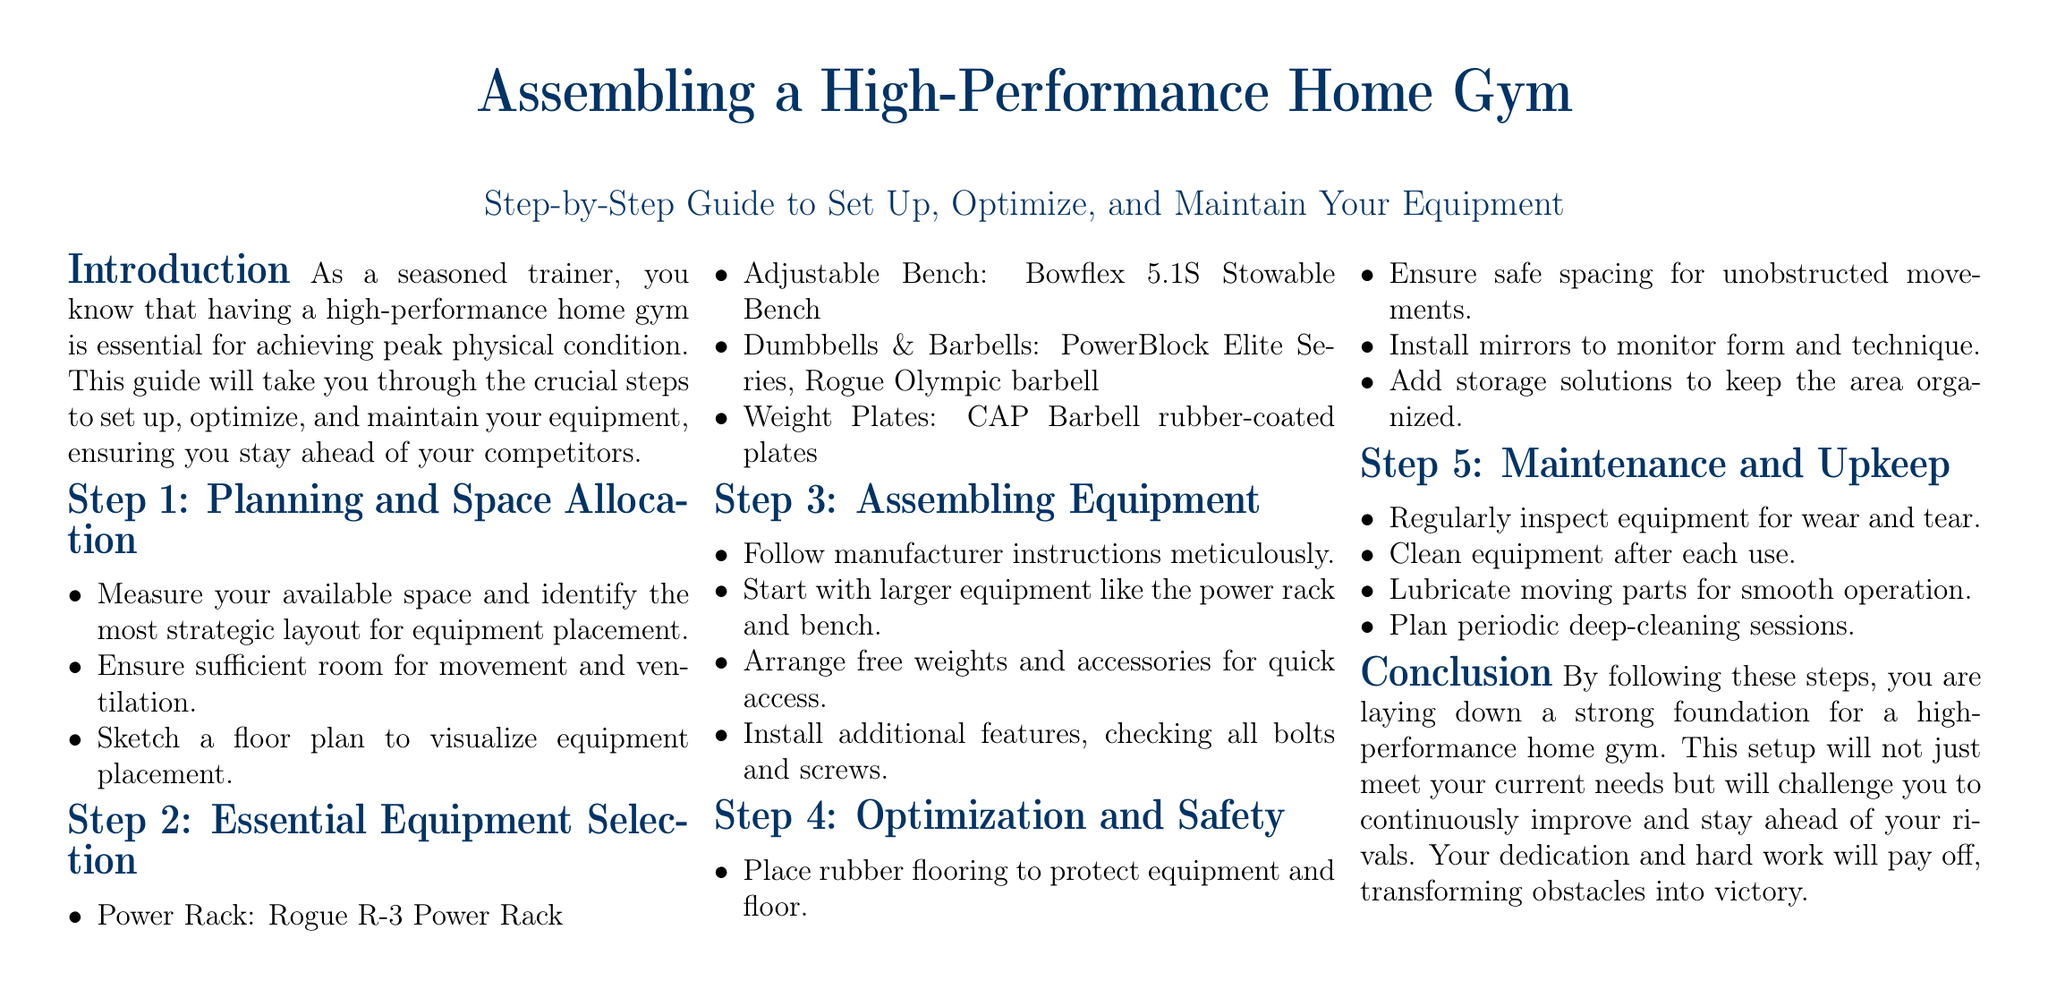What is the first step in assembling a home gym? The first step is planning and space allocation, as indicated in the document.
Answer: Planning and space allocation Which power rack is recommended? The document specifies the Rogue R-3 Power Rack as the recommended equipment.
Answer: Rogue R-3 Power Rack What type of flooring should be installed? Rubber flooring is suggested to protect equipment and the floor.
Answer: Rubber flooring How should equipment be arranged for access? The document advises arranging free weights and accessories for quick access.
Answer: Quick access What is the purpose of installing mirrors? Mirrors are mentioned to monitor form and technique during workouts.
Answer: Monitor form and technique How often should equipment be inspected? The document implies that equipment should be regularly inspected for wear and tear.
Answer: Regularly What is one of the essential items to clean after each use? Cleaning the equipment after each use is highlighted in the maintenance section of the document.
Answer: Equipment Which adjustable bench is mentioned? The Bowflex 5.1S Stowable Bench is noted as the adjustable bench to select.
Answer: Bowflex 5.1S Stowable Bench What should be included in the optimization step? Adding storage solutions is one of the steps indicated for optimization.
Answer: Storage solutions 